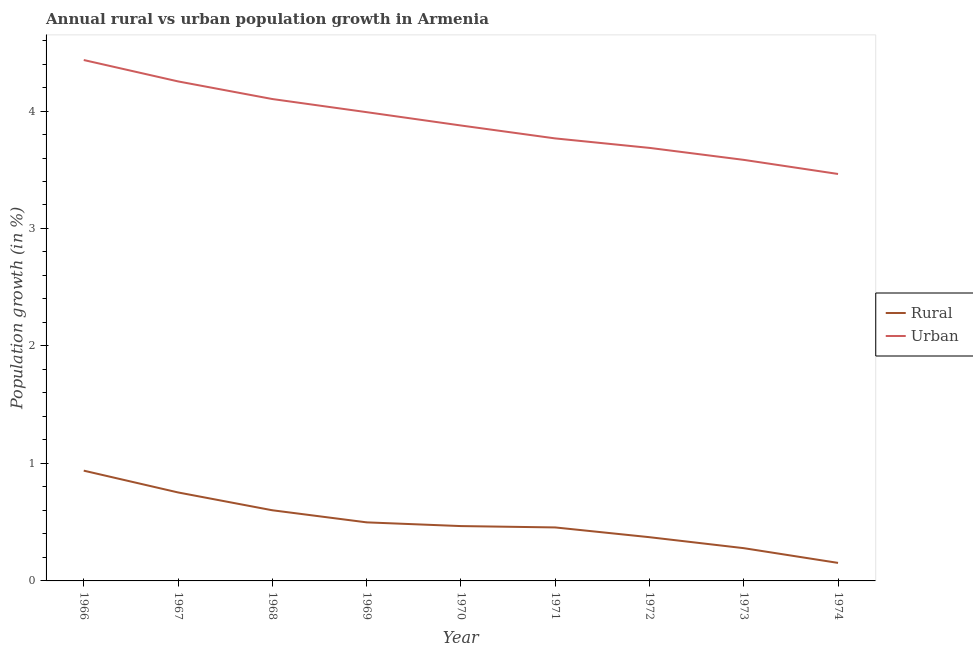Is the number of lines equal to the number of legend labels?
Your answer should be compact. Yes. What is the urban population growth in 1974?
Ensure brevity in your answer.  3.46. Across all years, what is the maximum urban population growth?
Provide a succinct answer. 4.43. Across all years, what is the minimum urban population growth?
Your answer should be compact. 3.46. In which year was the urban population growth maximum?
Your answer should be compact. 1966. In which year was the rural population growth minimum?
Your answer should be compact. 1974. What is the total urban population growth in the graph?
Keep it short and to the point. 35.16. What is the difference between the rural population growth in 1971 and that in 1972?
Your response must be concise. 0.08. What is the difference between the urban population growth in 1970 and the rural population growth in 1967?
Make the answer very short. 3.12. What is the average urban population growth per year?
Provide a succinct answer. 3.91. In the year 1973, what is the difference between the urban population growth and rural population growth?
Offer a terse response. 3.31. In how many years, is the urban population growth greater than 3 %?
Provide a short and direct response. 9. What is the ratio of the rural population growth in 1967 to that in 1973?
Keep it short and to the point. 2.7. What is the difference between the highest and the second highest urban population growth?
Provide a succinct answer. 0.18. What is the difference between the highest and the lowest urban population growth?
Offer a terse response. 0.97. In how many years, is the urban population growth greater than the average urban population growth taken over all years?
Provide a short and direct response. 4. Is the rural population growth strictly greater than the urban population growth over the years?
Keep it short and to the point. No. Is the rural population growth strictly less than the urban population growth over the years?
Provide a short and direct response. Yes. What is the difference between two consecutive major ticks on the Y-axis?
Offer a very short reply. 1. Does the graph contain grids?
Provide a succinct answer. No. Where does the legend appear in the graph?
Ensure brevity in your answer.  Center right. How are the legend labels stacked?
Make the answer very short. Vertical. What is the title of the graph?
Your answer should be compact. Annual rural vs urban population growth in Armenia. What is the label or title of the X-axis?
Give a very brief answer. Year. What is the label or title of the Y-axis?
Provide a short and direct response. Population growth (in %). What is the Population growth (in %) in Rural in 1966?
Your answer should be very brief. 0.94. What is the Population growth (in %) in Urban  in 1966?
Offer a very short reply. 4.43. What is the Population growth (in %) in Rural in 1967?
Make the answer very short. 0.75. What is the Population growth (in %) in Urban  in 1967?
Offer a terse response. 4.25. What is the Population growth (in %) in Rural in 1968?
Give a very brief answer. 0.6. What is the Population growth (in %) in Urban  in 1968?
Offer a terse response. 4.1. What is the Population growth (in %) in Rural in 1969?
Your response must be concise. 0.5. What is the Population growth (in %) in Urban  in 1969?
Your answer should be compact. 3.99. What is the Population growth (in %) in Rural in 1970?
Your answer should be compact. 0.47. What is the Population growth (in %) of Urban  in 1970?
Your answer should be compact. 3.88. What is the Population growth (in %) of Rural in 1971?
Make the answer very short. 0.46. What is the Population growth (in %) in Urban  in 1971?
Give a very brief answer. 3.77. What is the Population growth (in %) in Rural in 1972?
Offer a very short reply. 0.37. What is the Population growth (in %) in Urban  in 1972?
Provide a succinct answer. 3.69. What is the Population growth (in %) in Rural in 1973?
Offer a terse response. 0.28. What is the Population growth (in %) of Urban  in 1973?
Give a very brief answer. 3.58. What is the Population growth (in %) in Rural in 1974?
Your response must be concise. 0.15. What is the Population growth (in %) of Urban  in 1974?
Make the answer very short. 3.46. Across all years, what is the maximum Population growth (in %) of Rural?
Make the answer very short. 0.94. Across all years, what is the maximum Population growth (in %) of Urban ?
Offer a terse response. 4.43. Across all years, what is the minimum Population growth (in %) in Rural?
Your answer should be compact. 0.15. Across all years, what is the minimum Population growth (in %) in Urban ?
Your answer should be compact. 3.46. What is the total Population growth (in %) of Rural in the graph?
Your answer should be very brief. 4.52. What is the total Population growth (in %) in Urban  in the graph?
Give a very brief answer. 35.16. What is the difference between the Population growth (in %) of Rural in 1966 and that in 1967?
Keep it short and to the point. 0.19. What is the difference between the Population growth (in %) of Urban  in 1966 and that in 1967?
Ensure brevity in your answer.  0.18. What is the difference between the Population growth (in %) in Rural in 1966 and that in 1968?
Your answer should be compact. 0.34. What is the difference between the Population growth (in %) of Urban  in 1966 and that in 1968?
Keep it short and to the point. 0.33. What is the difference between the Population growth (in %) of Rural in 1966 and that in 1969?
Keep it short and to the point. 0.44. What is the difference between the Population growth (in %) in Urban  in 1966 and that in 1969?
Give a very brief answer. 0.44. What is the difference between the Population growth (in %) in Rural in 1966 and that in 1970?
Keep it short and to the point. 0.47. What is the difference between the Population growth (in %) of Urban  in 1966 and that in 1970?
Your answer should be very brief. 0.56. What is the difference between the Population growth (in %) in Rural in 1966 and that in 1971?
Offer a terse response. 0.48. What is the difference between the Population growth (in %) in Urban  in 1966 and that in 1971?
Your answer should be very brief. 0.67. What is the difference between the Population growth (in %) of Rural in 1966 and that in 1972?
Ensure brevity in your answer.  0.57. What is the difference between the Population growth (in %) in Urban  in 1966 and that in 1972?
Your answer should be compact. 0.75. What is the difference between the Population growth (in %) in Rural in 1966 and that in 1973?
Your response must be concise. 0.66. What is the difference between the Population growth (in %) of Urban  in 1966 and that in 1973?
Your answer should be very brief. 0.85. What is the difference between the Population growth (in %) in Rural in 1966 and that in 1974?
Make the answer very short. 0.79. What is the difference between the Population growth (in %) in Urban  in 1966 and that in 1974?
Make the answer very short. 0.97. What is the difference between the Population growth (in %) in Rural in 1967 and that in 1968?
Your response must be concise. 0.15. What is the difference between the Population growth (in %) in Urban  in 1967 and that in 1968?
Give a very brief answer. 0.15. What is the difference between the Population growth (in %) in Rural in 1967 and that in 1969?
Make the answer very short. 0.25. What is the difference between the Population growth (in %) of Urban  in 1967 and that in 1969?
Ensure brevity in your answer.  0.26. What is the difference between the Population growth (in %) of Rural in 1967 and that in 1970?
Offer a terse response. 0.29. What is the difference between the Population growth (in %) of Urban  in 1967 and that in 1970?
Offer a terse response. 0.38. What is the difference between the Population growth (in %) of Rural in 1967 and that in 1971?
Your answer should be compact. 0.3. What is the difference between the Population growth (in %) in Urban  in 1967 and that in 1971?
Keep it short and to the point. 0.49. What is the difference between the Population growth (in %) in Rural in 1967 and that in 1972?
Your response must be concise. 0.38. What is the difference between the Population growth (in %) of Urban  in 1967 and that in 1972?
Offer a terse response. 0.57. What is the difference between the Population growth (in %) of Rural in 1967 and that in 1973?
Offer a very short reply. 0.47. What is the difference between the Population growth (in %) of Urban  in 1967 and that in 1973?
Keep it short and to the point. 0.67. What is the difference between the Population growth (in %) in Rural in 1967 and that in 1974?
Offer a terse response. 0.6. What is the difference between the Population growth (in %) of Urban  in 1967 and that in 1974?
Provide a short and direct response. 0.79. What is the difference between the Population growth (in %) of Rural in 1968 and that in 1969?
Provide a succinct answer. 0.1. What is the difference between the Population growth (in %) of Urban  in 1968 and that in 1969?
Your answer should be very brief. 0.11. What is the difference between the Population growth (in %) of Rural in 1968 and that in 1970?
Offer a very short reply. 0.13. What is the difference between the Population growth (in %) in Urban  in 1968 and that in 1970?
Provide a short and direct response. 0.23. What is the difference between the Population growth (in %) of Rural in 1968 and that in 1971?
Your answer should be very brief. 0.15. What is the difference between the Population growth (in %) of Urban  in 1968 and that in 1971?
Your response must be concise. 0.34. What is the difference between the Population growth (in %) of Rural in 1968 and that in 1972?
Your answer should be compact. 0.23. What is the difference between the Population growth (in %) in Urban  in 1968 and that in 1972?
Your response must be concise. 0.42. What is the difference between the Population growth (in %) of Rural in 1968 and that in 1973?
Ensure brevity in your answer.  0.32. What is the difference between the Population growth (in %) in Urban  in 1968 and that in 1973?
Make the answer very short. 0.52. What is the difference between the Population growth (in %) of Rural in 1968 and that in 1974?
Provide a short and direct response. 0.45. What is the difference between the Population growth (in %) in Urban  in 1968 and that in 1974?
Make the answer very short. 0.64. What is the difference between the Population growth (in %) in Rural in 1969 and that in 1970?
Offer a very short reply. 0.03. What is the difference between the Population growth (in %) in Urban  in 1969 and that in 1970?
Your answer should be compact. 0.11. What is the difference between the Population growth (in %) in Rural in 1969 and that in 1971?
Offer a very short reply. 0.04. What is the difference between the Population growth (in %) in Urban  in 1969 and that in 1971?
Provide a short and direct response. 0.22. What is the difference between the Population growth (in %) of Rural in 1969 and that in 1972?
Your response must be concise. 0.13. What is the difference between the Population growth (in %) of Urban  in 1969 and that in 1972?
Offer a terse response. 0.3. What is the difference between the Population growth (in %) in Rural in 1969 and that in 1973?
Provide a short and direct response. 0.22. What is the difference between the Population growth (in %) of Urban  in 1969 and that in 1973?
Provide a succinct answer. 0.41. What is the difference between the Population growth (in %) in Rural in 1969 and that in 1974?
Your answer should be compact. 0.35. What is the difference between the Population growth (in %) of Urban  in 1969 and that in 1974?
Offer a terse response. 0.53. What is the difference between the Population growth (in %) of Rural in 1970 and that in 1971?
Keep it short and to the point. 0.01. What is the difference between the Population growth (in %) in Urban  in 1970 and that in 1971?
Provide a short and direct response. 0.11. What is the difference between the Population growth (in %) in Rural in 1970 and that in 1972?
Make the answer very short. 0.09. What is the difference between the Population growth (in %) in Urban  in 1970 and that in 1972?
Your answer should be very brief. 0.19. What is the difference between the Population growth (in %) in Rural in 1970 and that in 1973?
Your answer should be very brief. 0.19. What is the difference between the Population growth (in %) in Urban  in 1970 and that in 1973?
Make the answer very short. 0.29. What is the difference between the Population growth (in %) of Rural in 1970 and that in 1974?
Ensure brevity in your answer.  0.31. What is the difference between the Population growth (in %) of Urban  in 1970 and that in 1974?
Provide a short and direct response. 0.41. What is the difference between the Population growth (in %) in Rural in 1971 and that in 1972?
Your answer should be compact. 0.08. What is the difference between the Population growth (in %) in Urban  in 1971 and that in 1972?
Ensure brevity in your answer.  0.08. What is the difference between the Population growth (in %) of Rural in 1971 and that in 1973?
Offer a terse response. 0.18. What is the difference between the Population growth (in %) in Urban  in 1971 and that in 1973?
Ensure brevity in your answer.  0.18. What is the difference between the Population growth (in %) in Rural in 1971 and that in 1974?
Your answer should be very brief. 0.3. What is the difference between the Population growth (in %) in Urban  in 1971 and that in 1974?
Your answer should be compact. 0.3. What is the difference between the Population growth (in %) in Rural in 1972 and that in 1973?
Offer a terse response. 0.09. What is the difference between the Population growth (in %) of Urban  in 1972 and that in 1973?
Your answer should be compact. 0.1. What is the difference between the Population growth (in %) in Rural in 1972 and that in 1974?
Ensure brevity in your answer.  0.22. What is the difference between the Population growth (in %) of Urban  in 1972 and that in 1974?
Ensure brevity in your answer.  0.22. What is the difference between the Population growth (in %) in Rural in 1973 and that in 1974?
Provide a succinct answer. 0.13. What is the difference between the Population growth (in %) in Urban  in 1973 and that in 1974?
Provide a short and direct response. 0.12. What is the difference between the Population growth (in %) in Rural in 1966 and the Population growth (in %) in Urban  in 1967?
Your answer should be compact. -3.31. What is the difference between the Population growth (in %) in Rural in 1966 and the Population growth (in %) in Urban  in 1968?
Offer a very short reply. -3.16. What is the difference between the Population growth (in %) in Rural in 1966 and the Population growth (in %) in Urban  in 1969?
Your response must be concise. -3.05. What is the difference between the Population growth (in %) of Rural in 1966 and the Population growth (in %) of Urban  in 1970?
Your response must be concise. -2.94. What is the difference between the Population growth (in %) in Rural in 1966 and the Population growth (in %) in Urban  in 1971?
Provide a short and direct response. -2.83. What is the difference between the Population growth (in %) of Rural in 1966 and the Population growth (in %) of Urban  in 1972?
Your answer should be very brief. -2.75. What is the difference between the Population growth (in %) of Rural in 1966 and the Population growth (in %) of Urban  in 1973?
Your response must be concise. -2.65. What is the difference between the Population growth (in %) in Rural in 1966 and the Population growth (in %) in Urban  in 1974?
Offer a very short reply. -2.53. What is the difference between the Population growth (in %) in Rural in 1967 and the Population growth (in %) in Urban  in 1968?
Your answer should be very brief. -3.35. What is the difference between the Population growth (in %) of Rural in 1967 and the Population growth (in %) of Urban  in 1969?
Your answer should be very brief. -3.24. What is the difference between the Population growth (in %) of Rural in 1967 and the Population growth (in %) of Urban  in 1970?
Ensure brevity in your answer.  -3.12. What is the difference between the Population growth (in %) in Rural in 1967 and the Population growth (in %) in Urban  in 1971?
Make the answer very short. -3.01. What is the difference between the Population growth (in %) of Rural in 1967 and the Population growth (in %) of Urban  in 1972?
Ensure brevity in your answer.  -2.93. What is the difference between the Population growth (in %) of Rural in 1967 and the Population growth (in %) of Urban  in 1973?
Provide a short and direct response. -2.83. What is the difference between the Population growth (in %) of Rural in 1967 and the Population growth (in %) of Urban  in 1974?
Make the answer very short. -2.71. What is the difference between the Population growth (in %) of Rural in 1968 and the Population growth (in %) of Urban  in 1969?
Your response must be concise. -3.39. What is the difference between the Population growth (in %) in Rural in 1968 and the Population growth (in %) in Urban  in 1970?
Offer a terse response. -3.28. What is the difference between the Population growth (in %) of Rural in 1968 and the Population growth (in %) of Urban  in 1971?
Keep it short and to the point. -3.17. What is the difference between the Population growth (in %) of Rural in 1968 and the Population growth (in %) of Urban  in 1972?
Offer a terse response. -3.08. What is the difference between the Population growth (in %) of Rural in 1968 and the Population growth (in %) of Urban  in 1973?
Ensure brevity in your answer.  -2.98. What is the difference between the Population growth (in %) in Rural in 1968 and the Population growth (in %) in Urban  in 1974?
Your answer should be very brief. -2.86. What is the difference between the Population growth (in %) in Rural in 1969 and the Population growth (in %) in Urban  in 1970?
Provide a short and direct response. -3.38. What is the difference between the Population growth (in %) in Rural in 1969 and the Population growth (in %) in Urban  in 1971?
Your response must be concise. -3.27. What is the difference between the Population growth (in %) of Rural in 1969 and the Population growth (in %) of Urban  in 1972?
Provide a short and direct response. -3.19. What is the difference between the Population growth (in %) of Rural in 1969 and the Population growth (in %) of Urban  in 1973?
Make the answer very short. -3.09. What is the difference between the Population growth (in %) in Rural in 1969 and the Population growth (in %) in Urban  in 1974?
Offer a terse response. -2.97. What is the difference between the Population growth (in %) of Rural in 1970 and the Population growth (in %) of Urban  in 1971?
Give a very brief answer. -3.3. What is the difference between the Population growth (in %) of Rural in 1970 and the Population growth (in %) of Urban  in 1972?
Offer a very short reply. -3.22. What is the difference between the Population growth (in %) of Rural in 1970 and the Population growth (in %) of Urban  in 1973?
Keep it short and to the point. -3.12. What is the difference between the Population growth (in %) in Rural in 1970 and the Population growth (in %) in Urban  in 1974?
Offer a terse response. -3. What is the difference between the Population growth (in %) of Rural in 1971 and the Population growth (in %) of Urban  in 1972?
Offer a terse response. -3.23. What is the difference between the Population growth (in %) in Rural in 1971 and the Population growth (in %) in Urban  in 1973?
Your answer should be very brief. -3.13. What is the difference between the Population growth (in %) of Rural in 1971 and the Population growth (in %) of Urban  in 1974?
Keep it short and to the point. -3.01. What is the difference between the Population growth (in %) in Rural in 1972 and the Population growth (in %) in Urban  in 1973?
Give a very brief answer. -3.21. What is the difference between the Population growth (in %) of Rural in 1972 and the Population growth (in %) of Urban  in 1974?
Give a very brief answer. -3.09. What is the difference between the Population growth (in %) of Rural in 1973 and the Population growth (in %) of Urban  in 1974?
Your response must be concise. -3.19. What is the average Population growth (in %) of Rural per year?
Offer a very short reply. 0.5. What is the average Population growth (in %) in Urban  per year?
Make the answer very short. 3.91. In the year 1966, what is the difference between the Population growth (in %) of Rural and Population growth (in %) of Urban ?
Offer a very short reply. -3.5. In the year 1967, what is the difference between the Population growth (in %) in Rural and Population growth (in %) in Urban ?
Offer a terse response. -3.5. In the year 1968, what is the difference between the Population growth (in %) in Rural and Population growth (in %) in Urban ?
Provide a succinct answer. -3.5. In the year 1969, what is the difference between the Population growth (in %) in Rural and Population growth (in %) in Urban ?
Offer a very short reply. -3.49. In the year 1970, what is the difference between the Population growth (in %) of Rural and Population growth (in %) of Urban ?
Your answer should be compact. -3.41. In the year 1971, what is the difference between the Population growth (in %) of Rural and Population growth (in %) of Urban ?
Provide a succinct answer. -3.31. In the year 1972, what is the difference between the Population growth (in %) of Rural and Population growth (in %) of Urban ?
Ensure brevity in your answer.  -3.31. In the year 1973, what is the difference between the Population growth (in %) in Rural and Population growth (in %) in Urban ?
Your answer should be very brief. -3.31. In the year 1974, what is the difference between the Population growth (in %) of Rural and Population growth (in %) of Urban ?
Your answer should be very brief. -3.31. What is the ratio of the Population growth (in %) in Rural in 1966 to that in 1967?
Provide a succinct answer. 1.25. What is the ratio of the Population growth (in %) of Urban  in 1966 to that in 1967?
Your response must be concise. 1.04. What is the ratio of the Population growth (in %) in Rural in 1966 to that in 1968?
Offer a very short reply. 1.56. What is the ratio of the Population growth (in %) of Urban  in 1966 to that in 1968?
Give a very brief answer. 1.08. What is the ratio of the Population growth (in %) of Rural in 1966 to that in 1969?
Your answer should be very brief. 1.88. What is the ratio of the Population growth (in %) in Urban  in 1966 to that in 1969?
Provide a succinct answer. 1.11. What is the ratio of the Population growth (in %) of Rural in 1966 to that in 1970?
Give a very brief answer. 2.01. What is the ratio of the Population growth (in %) of Urban  in 1966 to that in 1970?
Your answer should be compact. 1.14. What is the ratio of the Population growth (in %) in Rural in 1966 to that in 1971?
Offer a very short reply. 2.06. What is the ratio of the Population growth (in %) in Urban  in 1966 to that in 1971?
Make the answer very short. 1.18. What is the ratio of the Population growth (in %) of Rural in 1966 to that in 1972?
Your response must be concise. 2.52. What is the ratio of the Population growth (in %) of Urban  in 1966 to that in 1972?
Offer a terse response. 1.2. What is the ratio of the Population growth (in %) of Rural in 1966 to that in 1973?
Offer a very short reply. 3.37. What is the ratio of the Population growth (in %) in Urban  in 1966 to that in 1973?
Offer a very short reply. 1.24. What is the ratio of the Population growth (in %) of Rural in 1966 to that in 1974?
Make the answer very short. 6.12. What is the ratio of the Population growth (in %) in Urban  in 1966 to that in 1974?
Offer a very short reply. 1.28. What is the ratio of the Population growth (in %) of Rural in 1967 to that in 1968?
Ensure brevity in your answer.  1.25. What is the ratio of the Population growth (in %) of Urban  in 1967 to that in 1968?
Ensure brevity in your answer.  1.04. What is the ratio of the Population growth (in %) of Rural in 1967 to that in 1969?
Ensure brevity in your answer.  1.51. What is the ratio of the Population growth (in %) of Urban  in 1967 to that in 1969?
Ensure brevity in your answer.  1.07. What is the ratio of the Population growth (in %) in Rural in 1967 to that in 1970?
Make the answer very short. 1.61. What is the ratio of the Population growth (in %) of Urban  in 1967 to that in 1970?
Your answer should be compact. 1.1. What is the ratio of the Population growth (in %) in Rural in 1967 to that in 1971?
Offer a very short reply. 1.65. What is the ratio of the Population growth (in %) in Urban  in 1967 to that in 1971?
Your response must be concise. 1.13. What is the ratio of the Population growth (in %) of Rural in 1967 to that in 1972?
Offer a very short reply. 2.02. What is the ratio of the Population growth (in %) in Urban  in 1967 to that in 1972?
Keep it short and to the point. 1.15. What is the ratio of the Population growth (in %) in Rural in 1967 to that in 1973?
Ensure brevity in your answer.  2.7. What is the ratio of the Population growth (in %) in Urban  in 1967 to that in 1973?
Provide a succinct answer. 1.19. What is the ratio of the Population growth (in %) of Rural in 1967 to that in 1974?
Offer a terse response. 4.91. What is the ratio of the Population growth (in %) in Urban  in 1967 to that in 1974?
Provide a short and direct response. 1.23. What is the ratio of the Population growth (in %) of Rural in 1968 to that in 1969?
Your response must be concise. 1.21. What is the ratio of the Population growth (in %) of Urban  in 1968 to that in 1969?
Keep it short and to the point. 1.03. What is the ratio of the Population growth (in %) of Rural in 1968 to that in 1970?
Your response must be concise. 1.29. What is the ratio of the Population growth (in %) of Urban  in 1968 to that in 1970?
Your response must be concise. 1.06. What is the ratio of the Population growth (in %) in Rural in 1968 to that in 1971?
Offer a terse response. 1.32. What is the ratio of the Population growth (in %) of Urban  in 1968 to that in 1971?
Give a very brief answer. 1.09. What is the ratio of the Population growth (in %) in Rural in 1968 to that in 1972?
Your answer should be very brief. 1.62. What is the ratio of the Population growth (in %) in Urban  in 1968 to that in 1972?
Offer a terse response. 1.11. What is the ratio of the Population growth (in %) of Rural in 1968 to that in 1973?
Offer a terse response. 2.16. What is the ratio of the Population growth (in %) of Urban  in 1968 to that in 1973?
Keep it short and to the point. 1.14. What is the ratio of the Population growth (in %) of Rural in 1968 to that in 1974?
Provide a succinct answer. 3.92. What is the ratio of the Population growth (in %) in Urban  in 1968 to that in 1974?
Your response must be concise. 1.18. What is the ratio of the Population growth (in %) of Rural in 1969 to that in 1970?
Offer a very short reply. 1.07. What is the ratio of the Population growth (in %) in Urban  in 1969 to that in 1970?
Provide a short and direct response. 1.03. What is the ratio of the Population growth (in %) of Rural in 1969 to that in 1971?
Your response must be concise. 1.09. What is the ratio of the Population growth (in %) in Urban  in 1969 to that in 1971?
Offer a terse response. 1.06. What is the ratio of the Population growth (in %) in Rural in 1969 to that in 1972?
Make the answer very short. 1.34. What is the ratio of the Population growth (in %) of Urban  in 1969 to that in 1972?
Offer a terse response. 1.08. What is the ratio of the Population growth (in %) of Rural in 1969 to that in 1973?
Your answer should be very brief. 1.79. What is the ratio of the Population growth (in %) in Urban  in 1969 to that in 1973?
Give a very brief answer. 1.11. What is the ratio of the Population growth (in %) in Rural in 1969 to that in 1974?
Give a very brief answer. 3.25. What is the ratio of the Population growth (in %) in Urban  in 1969 to that in 1974?
Ensure brevity in your answer.  1.15. What is the ratio of the Population growth (in %) in Rural in 1970 to that in 1971?
Provide a succinct answer. 1.03. What is the ratio of the Population growth (in %) in Urban  in 1970 to that in 1971?
Offer a very short reply. 1.03. What is the ratio of the Population growth (in %) in Rural in 1970 to that in 1972?
Provide a short and direct response. 1.25. What is the ratio of the Population growth (in %) of Urban  in 1970 to that in 1972?
Your response must be concise. 1.05. What is the ratio of the Population growth (in %) of Rural in 1970 to that in 1973?
Provide a short and direct response. 1.67. What is the ratio of the Population growth (in %) in Urban  in 1970 to that in 1973?
Keep it short and to the point. 1.08. What is the ratio of the Population growth (in %) in Rural in 1970 to that in 1974?
Provide a succinct answer. 3.04. What is the ratio of the Population growth (in %) of Urban  in 1970 to that in 1974?
Offer a terse response. 1.12. What is the ratio of the Population growth (in %) in Rural in 1971 to that in 1972?
Your response must be concise. 1.22. What is the ratio of the Population growth (in %) in Urban  in 1971 to that in 1972?
Offer a very short reply. 1.02. What is the ratio of the Population growth (in %) in Rural in 1971 to that in 1973?
Make the answer very short. 1.63. What is the ratio of the Population growth (in %) in Urban  in 1971 to that in 1973?
Provide a succinct answer. 1.05. What is the ratio of the Population growth (in %) of Rural in 1971 to that in 1974?
Your answer should be very brief. 2.97. What is the ratio of the Population growth (in %) in Urban  in 1971 to that in 1974?
Your response must be concise. 1.09. What is the ratio of the Population growth (in %) of Rural in 1972 to that in 1973?
Your response must be concise. 1.33. What is the ratio of the Population growth (in %) in Urban  in 1972 to that in 1973?
Provide a succinct answer. 1.03. What is the ratio of the Population growth (in %) of Rural in 1972 to that in 1974?
Offer a terse response. 2.43. What is the ratio of the Population growth (in %) of Urban  in 1972 to that in 1974?
Give a very brief answer. 1.06. What is the ratio of the Population growth (in %) in Rural in 1973 to that in 1974?
Make the answer very short. 1.82. What is the ratio of the Population growth (in %) of Urban  in 1973 to that in 1974?
Your answer should be very brief. 1.03. What is the difference between the highest and the second highest Population growth (in %) of Rural?
Provide a short and direct response. 0.19. What is the difference between the highest and the second highest Population growth (in %) of Urban ?
Your response must be concise. 0.18. What is the difference between the highest and the lowest Population growth (in %) in Rural?
Your answer should be compact. 0.79. What is the difference between the highest and the lowest Population growth (in %) in Urban ?
Keep it short and to the point. 0.97. 